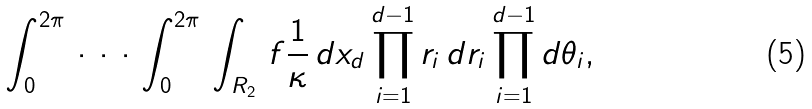Convert formula to latex. <formula><loc_0><loc_0><loc_500><loc_500>\, \int _ { 0 } ^ { 2 \pi } \, \cdot \, \cdot \, \cdot \, \int _ { 0 } ^ { 2 \pi } \, \int _ { R _ { 2 } } \, f \frac { 1 } { \kappa } \, d x _ { d } \prod _ { i = 1 } ^ { d - 1 } r _ { i } \, d r _ { i } \prod _ { i = 1 } ^ { d - 1 } d \theta _ { i } ,</formula> 